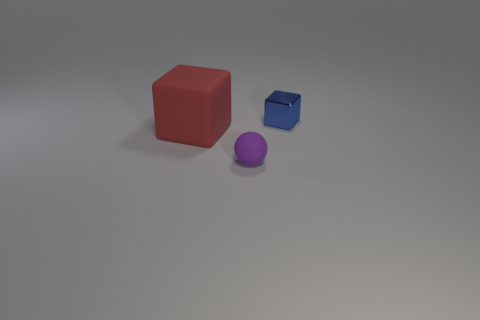Add 2 big matte things. How many objects exist? 5 Subtract all balls. How many objects are left? 2 Add 1 big gray cubes. How many big gray cubes exist? 1 Subtract 0 cyan blocks. How many objects are left? 3 Subtract all small purple matte spheres. Subtract all brown balls. How many objects are left? 2 Add 1 tiny metal cubes. How many tiny metal cubes are left? 2 